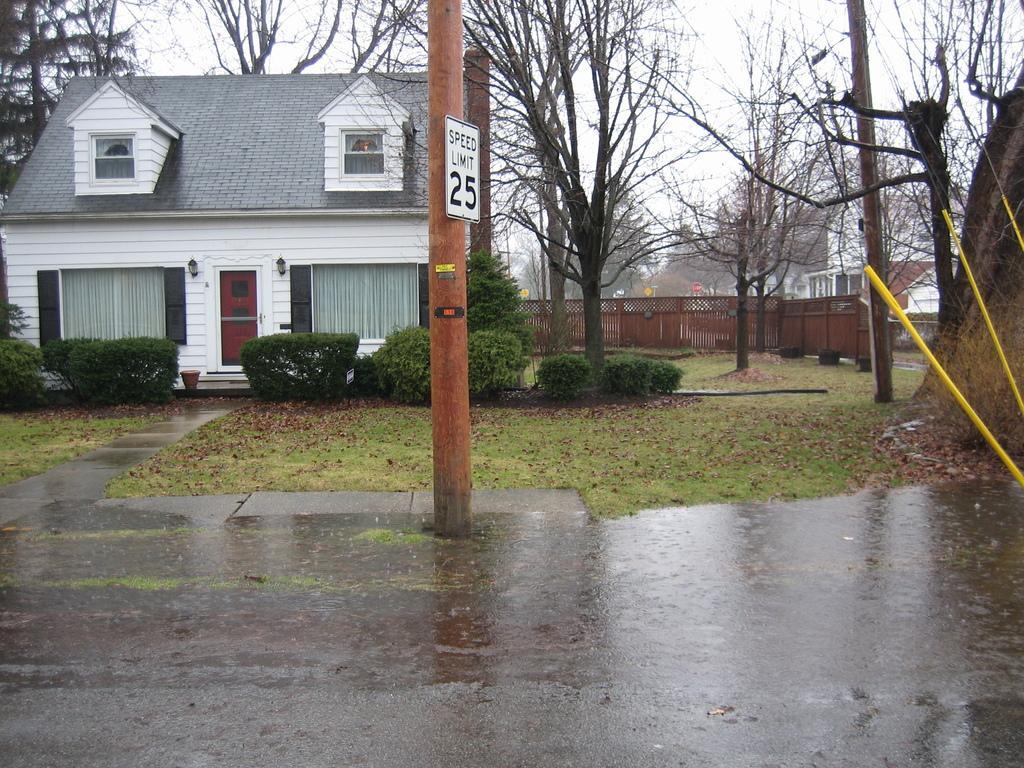Please provide a concise description of this image. In this picture there is a house and few plants in the left corner and there are few dried trees,buildings and some other objects in the background. 